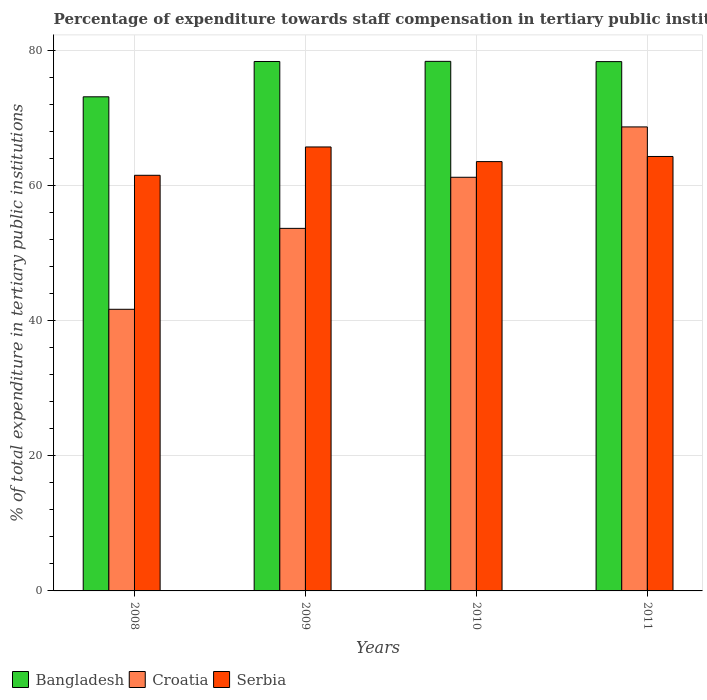How many groups of bars are there?
Offer a very short reply. 4. Are the number of bars on each tick of the X-axis equal?
Keep it short and to the point. Yes. What is the percentage of expenditure towards staff compensation in Croatia in 2009?
Make the answer very short. 53.69. Across all years, what is the maximum percentage of expenditure towards staff compensation in Croatia?
Your answer should be compact. 68.71. Across all years, what is the minimum percentage of expenditure towards staff compensation in Bangladesh?
Offer a terse response. 73.17. What is the total percentage of expenditure towards staff compensation in Bangladesh in the graph?
Provide a short and direct response. 308.37. What is the difference between the percentage of expenditure towards staff compensation in Bangladesh in 2008 and that in 2011?
Offer a terse response. -5.21. What is the difference between the percentage of expenditure towards staff compensation in Croatia in 2011 and the percentage of expenditure towards staff compensation in Serbia in 2010?
Your answer should be compact. 5.14. What is the average percentage of expenditure towards staff compensation in Croatia per year?
Ensure brevity in your answer.  56.34. In the year 2010, what is the difference between the percentage of expenditure towards staff compensation in Croatia and percentage of expenditure towards staff compensation in Serbia?
Give a very brief answer. -2.32. In how many years, is the percentage of expenditure towards staff compensation in Bangladesh greater than 32 %?
Provide a succinct answer. 4. What is the ratio of the percentage of expenditure towards staff compensation in Bangladesh in 2009 to that in 2010?
Your answer should be compact. 1. Is the percentage of expenditure towards staff compensation in Bangladesh in 2008 less than that in 2011?
Keep it short and to the point. Yes. Is the difference between the percentage of expenditure towards staff compensation in Croatia in 2008 and 2010 greater than the difference between the percentage of expenditure towards staff compensation in Serbia in 2008 and 2010?
Your response must be concise. No. What is the difference between the highest and the second highest percentage of expenditure towards staff compensation in Croatia?
Make the answer very short. 7.46. What is the difference between the highest and the lowest percentage of expenditure towards staff compensation in Croatia?
Give a very brief answer. 27.01. In how many years, is the percentage of expenditure towards staff compensation in Croatia greater than the average percentage of expenditure towards staff compensation in Croatia taken over all years?
Make the answer very short. 2. What does the 3rd bar from the left in 2008 represents?
Ensure brevity in your answer.  Serbia. What does the 2nd bar from the right in 2008 represents?
Make the answer very short. Croatia. How many bars are there?
Keep it short and to the point. 12. Are all the bars in the graph horizontal?
Offer a very short reply. No. Are the values on the major ticks of Y-axis written in scientific E-notation?
Your answer should be compact. No. Does the graph contain grids?
Offer a terse response. Yes. What is the title of the graph?
Offer a very short reply. Percentage of expenditure towards staff compensation in tertiary public institutions. What is the label or title of the X-axis?
Keep it short and to the point. Years. What is the label or title of the Y-axis?
Provide a short and direct response. % of total expenditure in tertiary public institutions. What is the % of total expenditure in tertiary public institutions of Bangladesh in 2008?
Provide a short and direct response. 73.17. What is the % of total expenditure in tertiary public institutions of Croatia in 2008?
Your response must be concise. 41.7. What is the % of total expenditure in tertiary public institutions in Serbia in 2008?
Provide a short and direct response. 61.55. What is the % of total expenditure in tertiary public institutions in Bangladesh in 2009?
Provide a short and direct response. 78.4. What is the % of total expenditure in tertiary public institutions in Croatia in 2009?
Provide a short and direct response. 53.69. What is the % of total expenditure in tertiary public institutions of Serbia in 2009?
Your answer should be compact. 65.74. What is the % of total expenditure in tertiary public institutions of Bangladesh in 2010?
Offer a terse response. 78.42. What is the % of total expenditure in tertiary public institutions in Croatia in 2010?
Keep it short and to the point. 61.25. What is the % of total expenditure in tertiary public institutions of Serbia in 2010?
Make the answer very short. 63.57. What is the % of total expenditure in tertiary public institutions of Bangladesh in 2011?
Your answer should be compact. 78.38. What is the % of total expenditure in tertiary public institutions of Croatia in 2011?
Your answer should be very brief. 68.71. What is the % of total expenditure in tertiary public institutions in Serbia in 2011?
Offer a very short reply. 64.33. Across all years, what is the maximum % of total expenditure in tertiary public institutions of Bangladesh?
Keep it short and to the point. 78.42. Across all years, what is the maximum % of total expenditure in tertiary public institutions of Croatia?
Your response must be concise. 68.71. Across all years, what is the maximum % of total expenditure in tertiary public institutions of Serbia?
Offer a terse response. 65.74. Across all years, what is the minimum % of total expenditure in tertiary public institutions of Bangladesh?
Provide a short and direct response. 73.17. Across all years, what is the minimum % of total expenditure in tertiary public institutions of Croatia?
Make the answer very short. 41.7. Across all years, what is the minimum % of total expenditure in tertiary public institutions of Serbia?
Your answer should be compact. 61.55. What is the total % of total expenditure in tertiary public institutions in Bangladesh in the graph?
Ensure brevity in your answer.  308.37. What is the total % of total expenditure in tertiary public institutions of Croatia in the graph?
Provide a short and direct response. 225.35. What is the total % of total expenditure in tertiary public institutions in Serbia in the graph?
Make the answer very short. 255.2. What is the difference between the % of total expenditure in tertiary public institutions in Bangladesh in 2008 and that in 2009?
Provide a succinct answer. -5.23. What is the difference between the % of total expenditure in tertiary public institutions in Croatia in 2008 and that in 2009?
Keep it short and to the point. -11.98. What is the difference between the % of total expenditure in tertiary public institutions in Serbia in 2008 and that in 2009?
Keep it short and to the point. -4.19. What is the difference between the % of total expenditure in tertiary public institutions of Bangladesh in 2008 and that in 2010?
Give a very brief answer. -5.25. What is the difference between the % of total expenditure in tertiary public institutions in Croatia in 2008 and that in 2010?
Provide a succinct answer. -19.55. What is the difference between the % of total expenditure in tertiary public institutions in Serbia in 2008 and that in 2010?
Your response must be concise. -2.03. What is the difference between the % of total expenditure in tertiary public institutions in Bangladesh in 2008 and that in 2011?
Offer a very short reply. -5.21. What is the difference between the % of total expenditure in tertiary public institutions of Croatia in 2008 and that in 2011?
Make the answer very short. -27.01. What is the difference between the % of total expenditure in tertiary public institutions in Serbia in 2008 and that in 2011?
Offer a very short reply. -2.79. What is the difference between the % of total expenditure in tertiary public institutions in Bangladesh in 2009 and that in 2010?
Give a very brief answer. -0.02. What is the difference between the % of total expenditure in tertiary public institutions in Croatia in 2009 and that in 2010?
Ensure brevity in your answer.  -7.57. What is the difference between the % of total expenditure in tertiary public institutions of Serbia in 2009 and that in 2010?
Make the answer very short. 2.17. What is the difference between the % of total expenditure in tertiary public institutions of Bangladesh in 2009 and that in 2011?
Provide a short and direct response. 0.02. What is the difference between the % of total expenditure in tertiary public institutions in Croatia in 2009 and that in 2011?
Your answer should be compact. -15.02. What is the difference between the % of total expenditure in tertiary public institutions of Serbia in 2009 and that in 2011?
Make the answer very short. 1.41. What is the difference between the % of total expenditure in tertiary public institutions in Bangladesh in 2010 and that in 2011?
Your answer should be very brief. 0.04. What is the difference between the % of total expenditure in tertiary public institutions of Croatia in 2010 and that in 2011?
Give a very brief answer. -7.46. What is the difference between the % of total expenditure in tertiary public institutions of Serbia in 2010 and that in 2011?
Give a very brief answer. -0.76. What is the difference between the % of total expenditure in tertiary public institutions of Bangladesh in 2008 and the % of total expenditure in tertiary public institutions of Croatia in 2009?
Offer a very short reply. 19.48. What is the difference between the % of total expenditure in tertiary public institutions in Bangladesh in 2008 and the % of total expenditure in tertiary public institutions in Serbia in 2009?
Make the answer very short. 7.43. What is the difference between the % of total expenditure in tertiary public institutions in Croatia in 2008 and the % of total expenditure in tertiary public institutions in Serbia in 2009?
Your answer should be very brief. -24.04. What is the difference between the % of total expenditure in tertiary public institutions of Bangladesh in 2008 and the % of total expenditure in tertiary public institutions of Croatia in 2010?
Keep it short and to the point. 11.92. What is the difference between the % of total expenditure in tertiary public institutions of Bangladesh in 2008 and the % of total expenditure in tertiary public institutions of Serbia in 2010?
Offer a very short reply. 9.6. What is the difference between the % of total expenditure in tertiary public institutions in Croatia in 2008 and the % of total expenditure in tertiary public institutions in Serbia in 2010?
Provide a succinct answer. -21.87. What is the difference between the % of total expenditure in tertiary public institutions of Bangladesh in 2008 and the % of total expenditure in tertiary public institutions of Croatia in 2011?
Offer a terse response. 4.46. What is the difference between the % of total expenditure in tertiary public institutions of Bangladesh in 2008 and the % of total expenditure in tertiary public institutions of Serbia in 2011?
Provide a short and direct response. 8.84. What is the difference between the % of total expenditure in tertiary public institutions in Croatia in 2008 and the % of total expenditure in tertiary public institutions in Serbia in 2011?
Give a very brief answer. -22.63. What is the difference between the % of total expenditure in tertiary public institutions in Bangladesh in 2009 and the % of total expenditure in tertiary public institutions in Croatia in 2010?
Ensure brevity in your answer.  17.14. What is the difference between the % of total expenditure in tertiary public institutions in Bangladesh in 2009 and the % of total expenditure in tertiary public institutions in Serbia in 2010?
Provide a succinct answer. 14.82. What is the difference between the % of total expenditure in tertiary public institutions of Croatia in 2009 and the % of total expenditure in tertiary public institutions of Serbia in 2010?
Provide a succinct answer. -9.89. What is the difference between the % of total expenditure in tertiary public institutions in Bangladesh in 2009 and the % of total expenditure in tertiary public institutions in Croatia in 2011?
Provide a short and direct response. 9.69. What is the difference between the % of total expenditure in tertiary public institutions in Bangladesh in 2009 and the % of total expenditure in tertiary public institutions in Serbia in 2011?
Your response must be concise. 14.06. What is the difference between the % of total expenditure in tertiary public institutions of Croatia in 2009 and the % of total expenditure in tertiary public institutions of Serbia in 2011?
Your answer should be very brief. -10.65. What is the difference between the % of total expenditure in tertiary public institutions of Bangladesh in 2010 and the % of total expenditure in tertiary public institutions of Croatia in 2011?
Provide a short and direct response. 9.71. What is the difference between the % of total expenditure in tertiary public institutions in Bangladesh in 2010 and the % of total expenditure in tertiary public institutions in Serbia in 2011?
Your answer should be compact. 14.09. What is the difference between the % of total expenditure in tertiary public institutions in Croatia in 2010 and the % of total expenditure in tertiary public institutions in Serbia in 2011?
Offer a terse response. -3.08. What is the average % of total expenditure in tertiary public institutions of Bangladesh per year?
Your answer should be compact. 77.09. What is the average % of total expenditure in tertiary public institutions in Croatia per year?
Offer a terse response. 56.34. What is the average % of total expenditure in tertiary public institutions in Serbia per year?
Ensure brevity in your answer.  63.8. In the year 2008, what is the difference between the % of total expenditure in tertiary public institutions in Bangladesh and % of total expenditure in tertiary public institutions in Croatia?
Provide a succinct answer. 31.47. In the year 2008, what is the difference between the % of total expenditure in tertiary public institutions in Bangladesh and % of total expenditure in tertiary public institutions in Serbia?
Ensure brevity in your answer.  11.62. In the year 2008, what is the difference between the % of total expenditure in tertiary public institutions in Croatia and % of total expenditure in tertiary public institutions in Serbia?
Give a very brief answer. -19.84. In the year 2009, what is the difference between the % of total expenditure in tertiary public institutions of Bangladesh and % of total expenditure in tertiary public institutions of Croatia?
Make the answer very short. 24.71. In the year 2009, what is the difference between the % of total expenditure in tertiary public institutions of Bangladesh and % of total expenditure in tertiary public institutions of Serbia?
Your answer should be very brief. 12.65. In the year 2009, what is the difference between the % of total expenditure in tertiary public institutions in Croatia and % of total expenditure in tertiary public institutions in Serbia?
Provide a succinct answer. -12.06. In the year 2010, what is the difference between the % of total expenditure in tertiary public institutions in Bangladesh and % of total expenditure in tertiary public institutions in Croatia?
Keep it short and to the point. 17.17. In the year 2010, what is the difference between the % of total expenditure in tertiary public institutions in Bangladesh and % of total expenditure in tertiary public institutions in Serbia?
Ensure brevity in your answer.  14.85. In the year 2010, what is the difference between the % of total expenditure in tertiary public institutions in Croatia and % of total expenditure in tertiary public institutions in Serbia?
Your answer should be compact. -2.32. In the year 2011, what is the difference between the % of total expenditure in tertiary public institutions of Bangladesh and % of total expenditure in tertiary public institutions of Croatia?
Offer a terse response. 9.67. In the year 2011, what is the difference between the % of total expenditure in tertiary public institutions in Bangladesh and % of total expenditure in tertiary public institutions in Serbia?
Your response must be concise. 14.05. In the year 2011, what is the difference between the % of total expenditure in tertiary public institutions of Croatia and % of total expenditure in tertiary public institutions of Serbia?
Offer a very short reply. 4.38. What is the ratio of the % of total expenditure in tertiary public institutions in Bangladesh in 2008 to that in 2009?
Provide a succinct answer. 0.93. What is the ratio of the % of total expenditure in tertiary public institutions of Croatia in 2008 to that in 2009?
Offer a very short reply. 0.78. What is the ratio of the % of total expenditure in tertiary public institutions in Serbia in 2008 to that in 2009?
Keep it short and to the point. 0.94. What is the ratio of the % of total expenditure in tertiary public institutions in Bangladesh in 2008 to that in 2010?
Provide a short and direct response. 0.93. What is the ratio of the % of total expenditure in tertiary public institutions in Croatia in 2008 to that in 2010?
Your response must be concise. 0.68. What is the ratio of the % of total expenditure in tertiary public institutions of Serbia in 2008 to that in 2010?
Your response must be concise. 0.97. What is the ratio of the % of total expenditure in tertiary public institutions in Bangladesh in 2008 to that in 2011?
Provide a succinct answer. 0.93. What is the ratio of the % of total expenditure in tertiary public institutions of Croatia in 2008 to that in 2011?
Give a very brief answer. 0.61. What is the ratio of the % of total expenditure in tertiary public institutions in Serbia in 2008 to that in 2011?
Keep it short and to the point. 0.96. What is the ratio of the % of total expenditure in tertiary public institutions of Croatia in 2009 to that in 2010?
Provide a short and direct response. 0.88. What is the ratio of the % of total expenditure in tertiary public institutions in Serbia in 2009 to that in 2010?
Make the answer very short. 1.03. What is the ratio of the % of total expenditure in tertiary public institutions of Croatia in 2009 to that in 2011?
Ensure brevity in your answer.  0.78. What is the ratio of the % of total expenditure in tertiary public institutions in Serbia in 2009 to that in 2011?
Your answer should be very brief. 1.02. What is the ratio of the % of total expenditure in tertiary public institutions of Croatia in 2010 to that in 2011?
Keep it short and to the point. 0.89. What is the ratio of the % of total expenditure in tertiary public institutions in Serbia in 2010 to that in 2011?
Keep it short and to the point. 0.99. What is the difference between the highest and the second highest % of total expenditure in tertiary public institutions of Bangladesh?
Your answer should be compact. 0.02. What is the difference between the highest and the second highest % of total expenditure in tertiary public institutions in Croatia?
Offer a very short reply. 7.46. What is the difference between the highest and the second highest % of total expenditure in tertiary public institutions of Serbia?
Your answer should be compact. 1.41. What is the difference between the highest and the lowest % of total expenditure in tertiary public institutions of Bangladesh?
Your response must be concise. 5.25. What is the difference between the highest and the lowest % of total expenditure in tertiary public institutions in Croatia?
Your response must be concise. 27.01. What is the difference between the highest and the lowest % of total expenditure in tertiary public institutions in Serbia?
Provide a short and direct response. 4.19. 